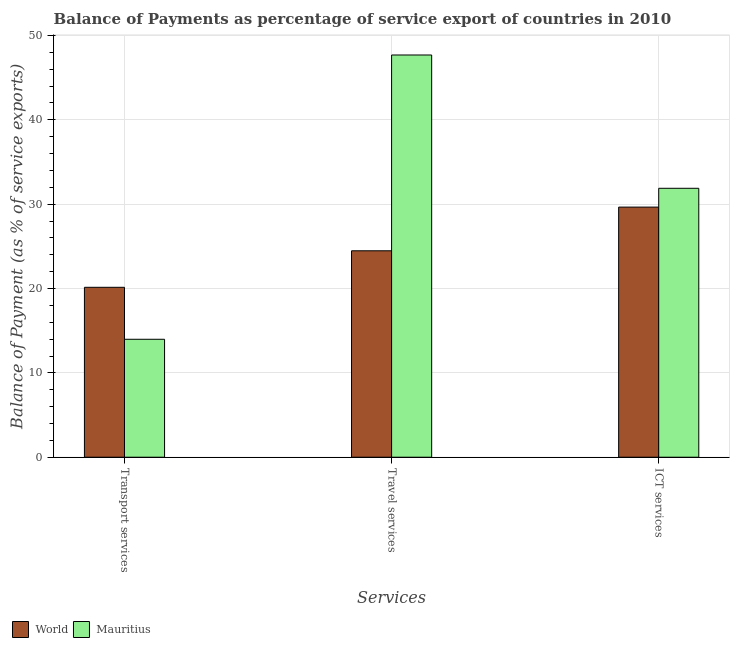Are the number of bars per tick equal to the number of legend labels?
Offer a very short reply. Yes. How many bars are there on the 3rd tick from the left?
Offer a terse response. 2. What is the label of the 1st group of bars from the left?
Offer a very short reply. Transport services. What is the balance of payment of ict services in Mauritius?
Offer a very short reply. 31.88. Across all countries, what is the maximum balance of payment of ict services?
Provide a short and direct response. 31.88. Across all countries, what is the minimum balance of payment of ict services?
Your response must be concise. 29.65. In which country was the balance of payment of transport services minimum?
Your answer should be very brief. Mauritius. What is the total balance of payment of ict services in the graph?
Your answer should be compact. 61.54. What is the difference between the balance of payment of ict services in Mauritius and that in World?
Give a very brief answer. 2.23. What is the difference between the balance of payment of ict services in World and the balance of payment of transport services in Mauritius?
Give a very brief answer. 15.67. What is the average balance of payment of ict services per country?
Provide a succinct answer. 30.77. What is the difference between the balance of payment of travel services and balance of payment of transport services in World?
Provide a short and direct response. 4.33. What is the ratio of the balance of payment of travel services in World to that in Mauritius?
Your answer should be compact. 0.51. Is the balance of payment of transport services in World less than that in Mauritius?
Give a very brief answer. No. Is the difference between the balance of payment of transport services in Mauritius and World greater than the difference between the balance of payment of travel services in Mauritius and World?
Offer a terse response. No. What is the difference between the highest and the second highest balance of payment of transport services?
Provide a short and direct response. 6.16. What is the difference between the highest and the lowest balance of payment of travel services?
Ensure brevity in your answer.  23.21. Is the sum of the balance of payment of travel services in World and Mauritius greater than the maximum balance of payment of transport services across all countries?
Provide a short and direct response. Yes. What does the 1st bar from the left in Travel services represents?
Ensure brevity in your answer.  World. Is it the case that in every country, the sum of the balance of payment of transport services and balance of payment of travel services is greater than the balance of payment of ict services?
Your answer should be very brief. Yes. Are all the bars in the graph horizontal?
Your response must be concise. No. How many countries are there in the graph?
Your answer should be very brief. 2. Does the graph contain grids?
Keep it short and to the point. Yes. How many legend labels are there?
Your answer should be compact. 2. How are the legend labels stacked?
Offer a terse response. Horizontal. What is the title of the graph?
Provide a succinct answer. Balance of Payments as percentage of service export of countries in 2010. Does "Jordan" appear as one of the legend labels in the graph?
Provide a succinct answer. No. What is the label or title of the X-axis?
Keep it short and to the point. Services. What is the label or title of the Y-axis?
Offer a terse response. Balance of Payment (as % of service exports). What is the Balance of Payment (as % of service exports) in World in Transport services?
Make the answer very short. 20.14. What is the Balance of Payment (as % of service exports) in Mauritius in Transport services?
Your answer should be compact. 13.98. What is the Balance of Payment (as % of service exports) of World in Travel services?
Give a very brief answer. 24.47. What is the Balance of Payment (as % of service exports) of Mauritius in Travel services?
Provide a short and direct response. 47.69. What is the Balance of Payment (as % of service exports) of World in ICT services?
Your answer should be compact. 29.65. What is the Balance of Payment (as % of service exports) of Mauritius in ICT services?
Your answer should be very brief. 31.88. Across all Services, what is the maximum Balance of Payment (as % of service exports) of World?
Keep it short and to the point. 29.65. Across all Services, what is the maximum Balance of Payment (as % of service exports) of Mauritius?
Your answer should be very brief. 47.69. Across all Services, what is the minimum Balance of Payment (as % of service exports) of World?
Offer a terse response. 20.14. Across all Services, what is the minimum Balance of Payment (as % of service exports) of Mauritius?
Keep it short and to the point. 13.98. What is the total Balance of Payment (as % of service exports) of World in the graph?
Make the answer very short. 74.27. What is the total Balance of Payment (as % of service exports) in Mauritius in the graph?
Make the answer very short. 93.56. What is the difference between the Balance of Payment (as % of service exports) in World in Transport services and that in Travel services?
Give a very brief answer. -4.33. What is the difference between the Balance of Payment (as % of service exports) in Mauritius in Transport services and that in Travel services?
Keep it short and to the point. -33.71. What is the difference between the Balance of Payment (as % of service exports) in World in Transport services and that in ICT services?
Ensure brevity in your answer.  -9.51. What is the difference between the Balance of Payment (as % of service exports) in Mauritius in Transport services and that in ICT services?
Keep it short and to the point. -17.9. What is the difference between the Balance of Payment (as % of service exports) of World in Travel services and that in ICT services?
Keep it short and to the point. -5.18. What is the difference between the Balance of Payment (as % of service exports) in Mauritius in Travel services and that in ICT services?
Give a very brief answer. 15.8. What is the difference between the Balance of Payment (as % of service exports) in World in Transport services and the Balance of Payment (as % of service exports) in Mauritius in Travel services?
Provide a short and direct response. -27.54. What is the difference between the Balance of Payment (as % of service exports) of World in Transport services and the Balance of Payment (as % of service exports) of Mauritius in ICT services?
Your answer should be very brief. -11.74. What is the difference between the Balance of Payment (as % of service exports) of World in Travel services and the Balance of Payment (as % of service exports) of Mauritius in ICT services?
Your answer should be compact. -7.41. What is the average Balance of Payment (as % of service exports) in World per Services?
Provide a succinct answer. 24.76. What is the average Balance of Payment (as % of service exports) in Mauritius per Services?
Your answer should be very brief. 31.19. What is the difference between the Balance of Payment (as % of service exports) of World and Balance of Payment (as % of service exports) of Mauritius in Transport services?
Your answer should be very brief. 6.16. What is the difference between the Balance of Payment (as % of service exports) of World and Balance of Payment (as % of service exports) of Mauritius in Travel services?
Offer a very short reply. -23.21. What is the difference between the Balance of Payment (as % of service exports) in World and Balance of Payment (as % of service exports) in Mauritius in ICT services?
Your answer should be very brief. -2.23. What is the ratio of the Balance of Payment (as % of service exports) of World in Transport services to that in Travel services?
Give a very brief answer. 0.82. What is the ratio of the Balance of Payment (as % of service exports) of Mauritius in Transport services to that in Travel services?
Provide a short and direct response. 0.29. What is the ratio of the Balance of Payment (as % of service exports) in World in Transport services to that in ICT services?
Provide a short and direct response. 0.68. What is the ratio of the Balance of Payment (as % of service exports) of Mauritius in Transport services to that in ICT services?
Make the answer very short. 0.44. What is the ratio of the Balance of Payment (as % of service exports) of World in Travel services to that in ICT services?
Your answer should be very brief. 0.83. What is the ratio of the Balance of Payment (as % of service exports) in Mauritius in Travel services to that in ICT services?
Your response must be concise. 1.5. What is the difference between the highest and the second highest Balance of Payment (as % of service exports) of World?
Give a very brief answer. 5.18. What is the difference between the highest and the second highest Balance of Payment (as % of service exports) of Mauritius?
Make the answer very short. 15.8. What is the difference between the highest and the lowest Balance of Payment (as % of service exports) of World?
Provide a succinct answer. 9.51. What is the difference between the highest and the lowest Balance of Payment (as % of service exports) of Mauritius?
Ensure brevity in your answer.  33.71. 